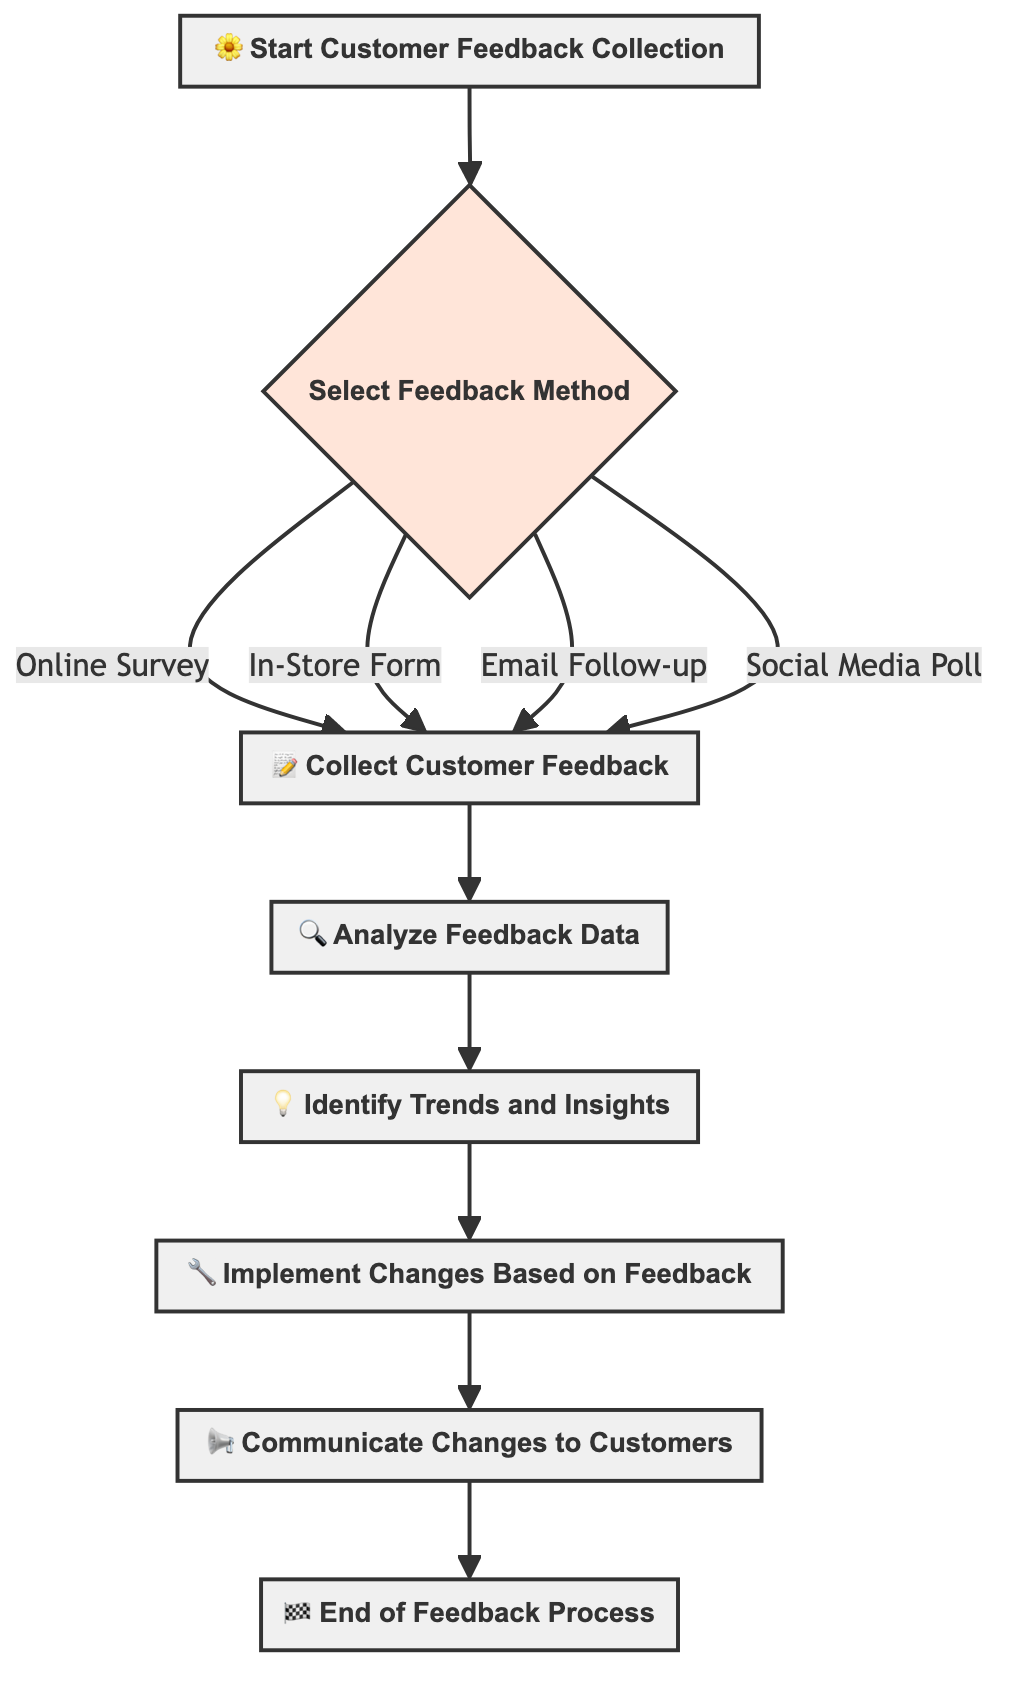What is the first step in the feedback collection flow? The first step is represented by the "Start Customer Feedback Collection" node. This node initiates the entire feedback process.
Answer: Start Customer Feedback Collection How many feedback methods are available in the decision node? The decision node "Select Feedback Method" lists four options for collecting feedback. Hence, there are four available methods.
Answer: Four Which process follows the "Collect Customer Feedback" step? After "Collect Customer Feedback," the flow leads to the "Analyze Feedback Data" process. This denotes a sequential progression from collecting feedback to analyzing it.
Answer: Analyze Feedback Data What is the last step in the feedback process? The last step is indicated by the "End of Feedback Process," which signifies the conclusion of all customer feedback activities.
Answer: End of Feedback Process What type of feedback can be collected according to the diagram? The diagram indicates four types of feedback collection methods, which include an online survey, in-store feedback form, email follow-up, and social media poll.
Answer: Online Survey, In-Store Feedback Form, Email Follow-up, Social Media Poll What is the relationship between "Identify Trends and Insights" and "Implement Changes"? The flow chart shows that "Identify Trends and Insights" directly leads to "Implement Changes Based on Feedback," indicating that identifying trends is a precursor to implementing changes.
Answer: Directly leads to How many processes are represented in the flowchart? The flowchart has six distinct processes, including "Collect Customer Feedback," "Analyze Feedback Data," "Identify Trends and Insights," "Implement Changes," "Communicate Changes to Customers," and the beginning and the end steps.
Answer: Six What action is taken after the trends are identified? Following the identification of trends, the process indicated is "Implement Changes Based on Feedback," which means actions are taken based on the insights gained.
Answer: Implement Changes Based on Feedback 